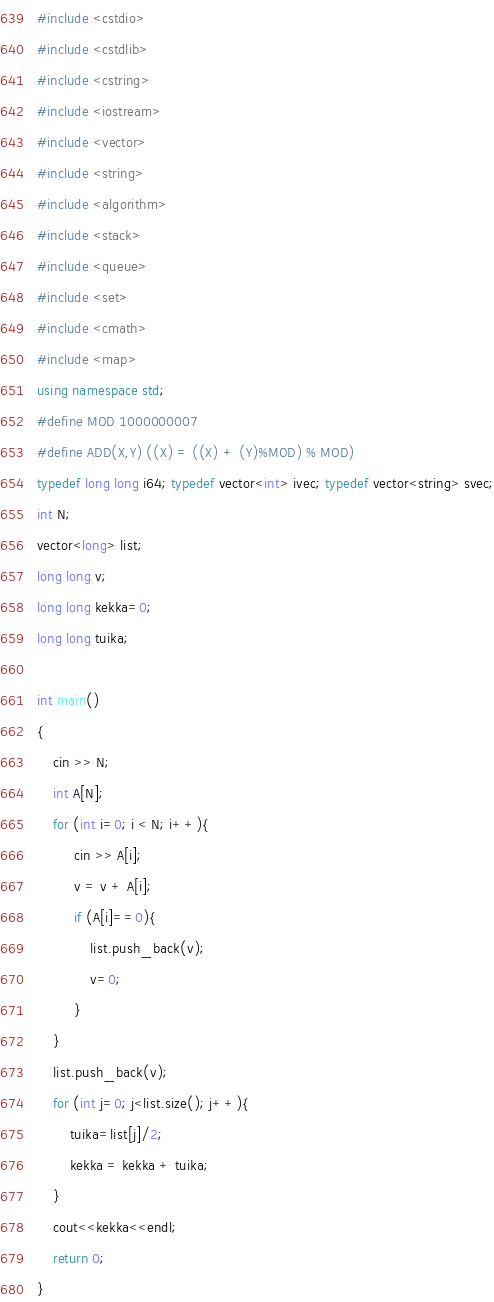<code> <loc_0><loc_0><loc_500><loc_500><_C++_>#include <cstdio>
#include <cstdlib>
#include <cstring>
#include <iostream>
#include <vector>
#include <string>
#include <algorithm>
#include <stack>
#include <queue>
#include <set>
#include <cmath>
#include <map>
using namespace std;
#define MOD 1000000007
#define ADD(X,Y) ((X) = ((X) + (Y)%MOD) % MOD)
typedef long long i64; typedef vector<int> ivec; typedef vector<string> svec;
int N;
vector<long> list;
long long v;
long long kekka=0;
long long tuika;

int main()
{
	cin >> N;
	int A[N];
	for (int i=0; i < N; i++){
		 cin >> A[i];
		 v = v + A[i];
		 if (A[i]==0){
			 list.push_back(v);
			 v=0;
		 }
	}
	list.push_back(v);
	for (int j=0; j<list.size(); j++){
		tuika=list[j]/2;
		kekka = kekka + tuika;
	}
	cout<<kekka<<endl;
	return 0;
}</code> 